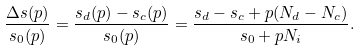Convert formula to latex. <formula><loc_0><loc_0><loc_500><loc_500>\frac { \Delta s ( p ) } { s _ { 0 } ( p ) } = \frac { s _ { d } ( p ) - s _ { c } ( p ) } { s _ { 0 } ( p ) } = \frac { s _ { d } - s _ { c } + p ( N _ { d } - N _ { c } ) } { s _ { 0 } + p N _ { i } } .</formula> 